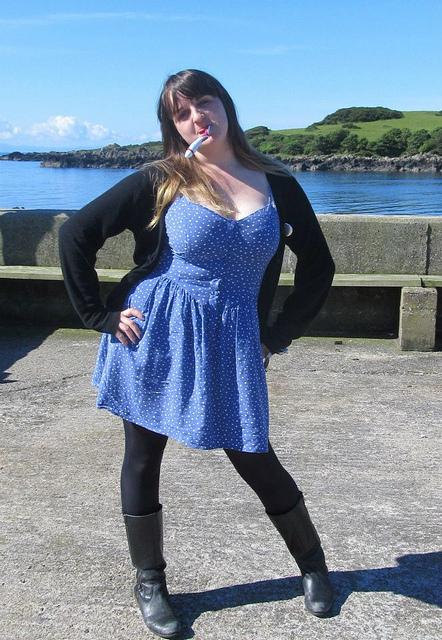To which direction of the woman is the sun located? left 